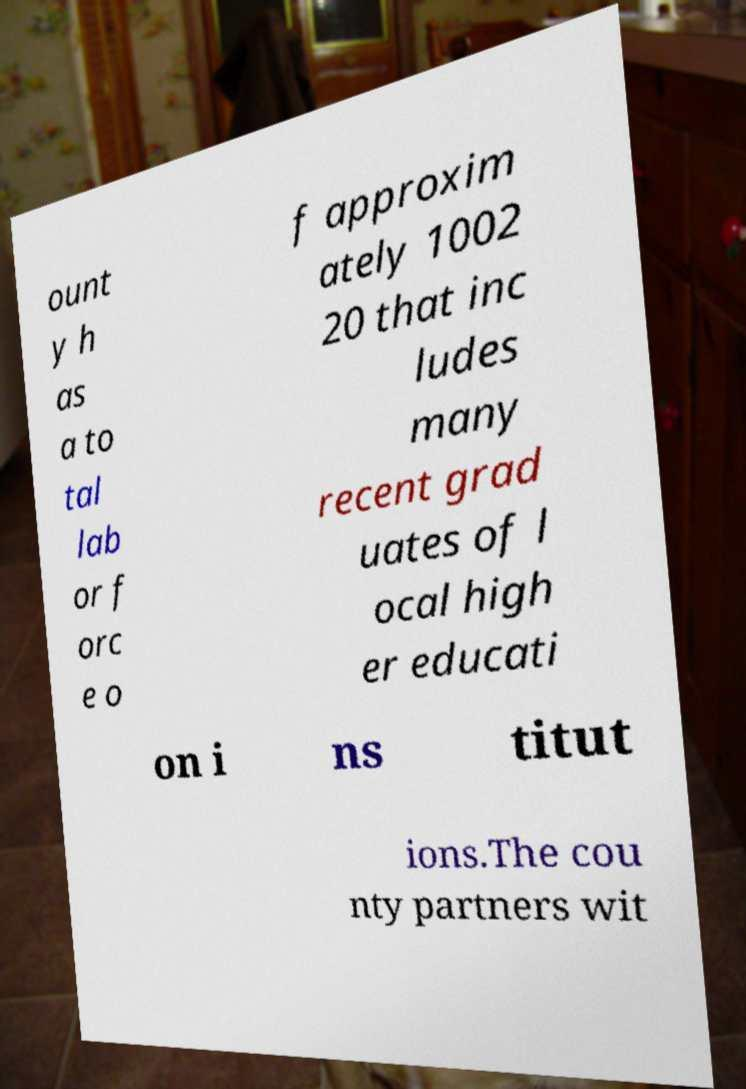Please read and relay the text visible in this image. What does it say? ount y h as a to tal lab or f orc e o f approxim ately 1002 20 that inc ludes many recent grad uates of l ocal high er educati on i ns titut ions.The cou nty partners wit 